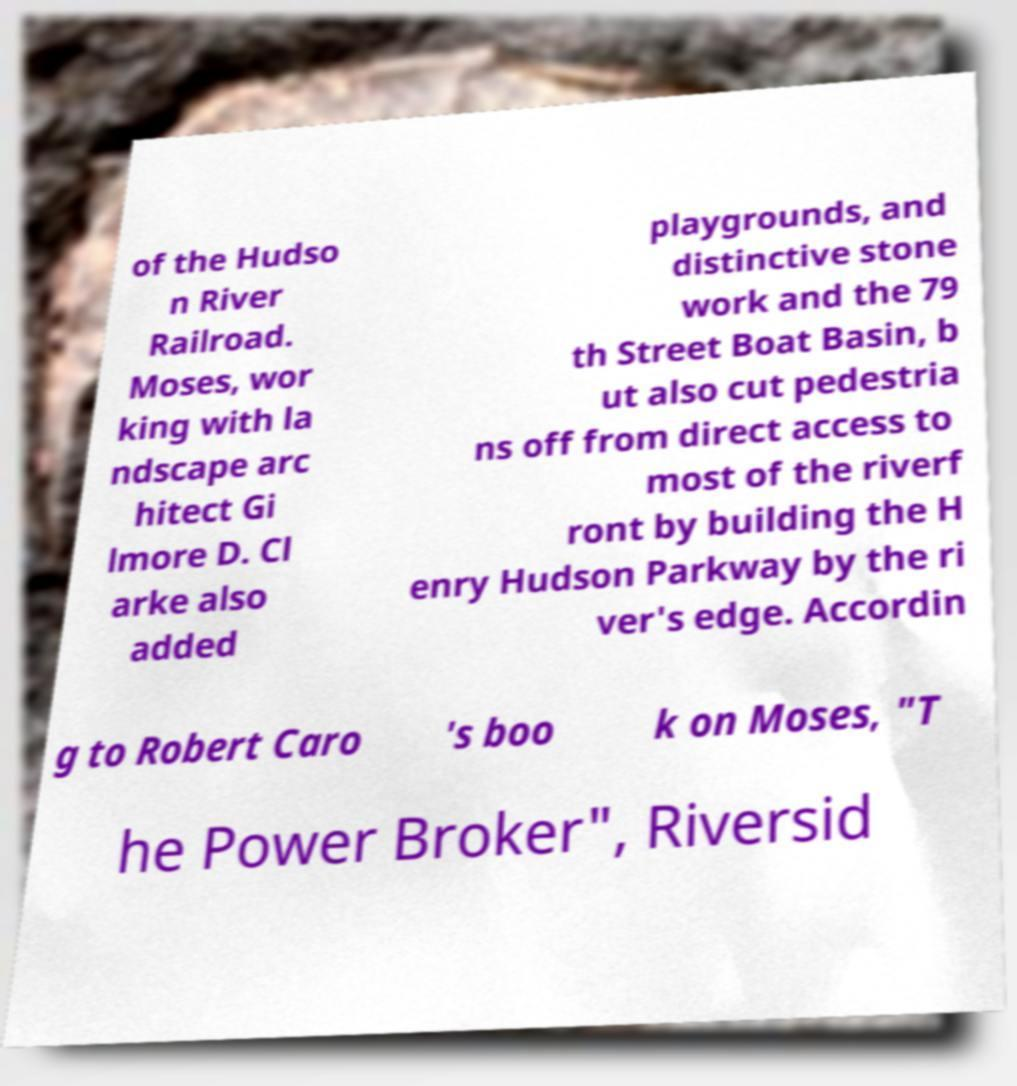There's text embedded in this image that I need extracted. Can you transcribe it verbatim? of the Hudso n River Railroad. Moses, wor king with la ndscape arc hitect Gi lmore D. Cl arke also added playgrounds, and distinctive stone work and the 79 th Street Boat Basin, b ut also cut pedestria ns off from direct access to most of the riverf ront by building the H enry Hudson Parkway by the ri ver's edge. Accordin g to Robert Caro 's boo k on Moses, "T he Power Broker", Riversid 